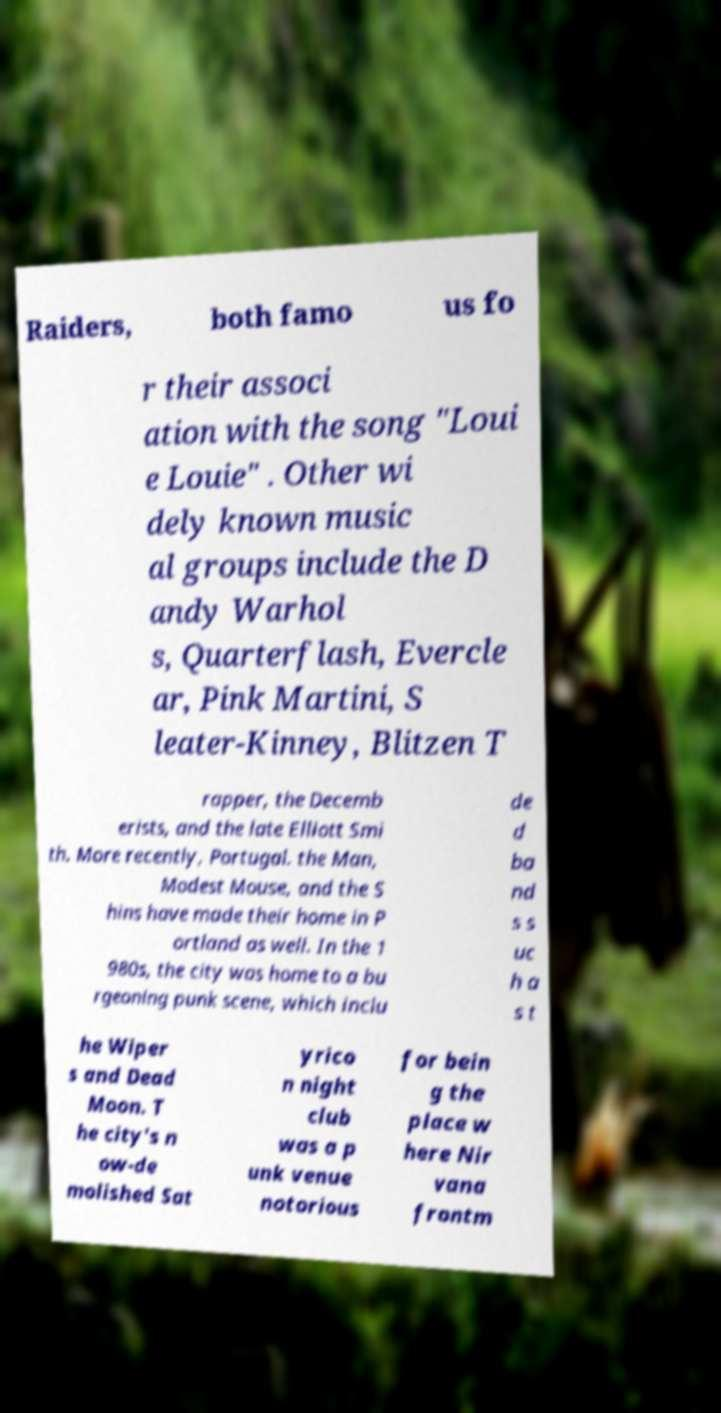Please identify and transcribe the text found in this image. Raiders, both famo us fo r their associ ation with the song "Loui e Louie" . Other wi dely known music al groups include the D andy Warhol s, Quarterflash, Evercle ar, Pink Martini, S leater-Kinney, Blitzen T rapper, the Decemb erists, and the late Elliott Smi th. More recently, Portugal. the Man, Modest Mouse, and the S hins have made their home in P ortland as well. In the 1 980s, the city was home to a bu rgeoning punk scene, which inclu de d ba nd s s uc h a s t he Wiper s and Dead Moon. T he city's n ow-de molished Sat yrico n night club was a p unk venue notorious for bein g the place w here Nir vana frontm 